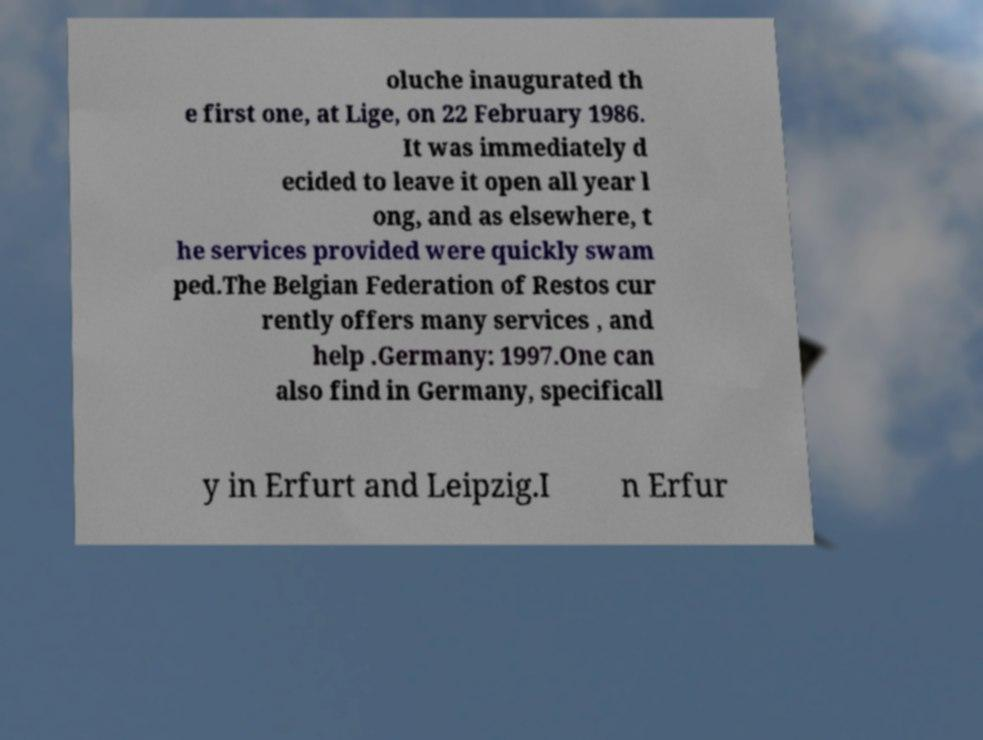Please read and relay the text visible in this image. What does it say? oluche inaugurated th e first one, at Lige, on 22 February 1986. It was immediately d ecided to leave it open all year l ong, and as elsewhere, t he services provided were quickly swam ped.The Belgian Federation of Restos cur rently offers many services , and help .Germany: 1997.One can also find in Germany, specificall y in Erfurt and Leipzig.I n Erfur 